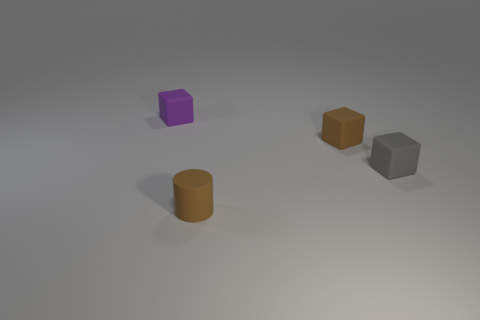If these objects were to be used in a simple physics experiment, which two would you choose and why? For a simple physics experiment, I would choose the purple cube and the brown cylinder in front. They have distinct shapes—a cube and a cylinder—which could be useful to demonstrate principles like how shape influences rolling and surface contact and its effects on motion. 